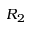<formula> <loc_0><loc_0><loc_500><loc_500>R _ { 2 }</formula> 